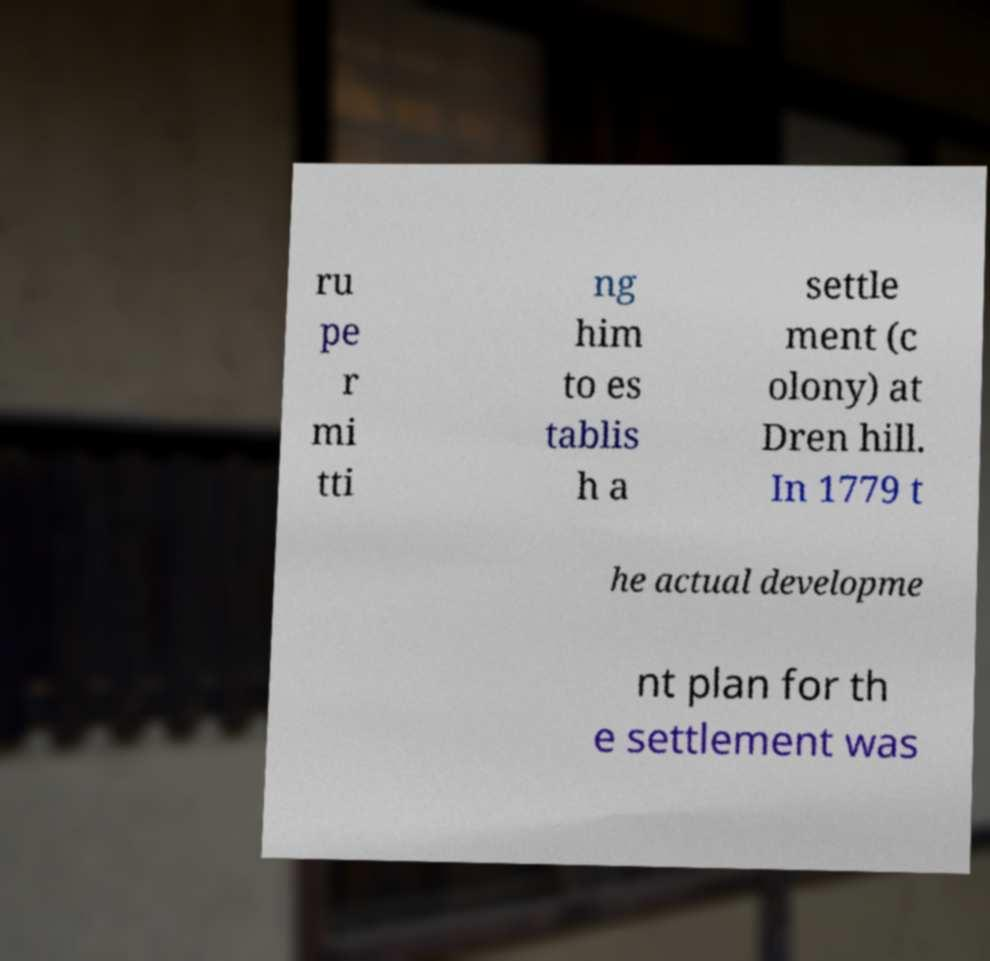What messages or text are displayed in this image? I need them in a readable, typed format. ru pe r mi tti ng him to es tablis h a settle ment (c olony) at Dren hill. In 1779 t he actual developme nt plan for th e settlement was 